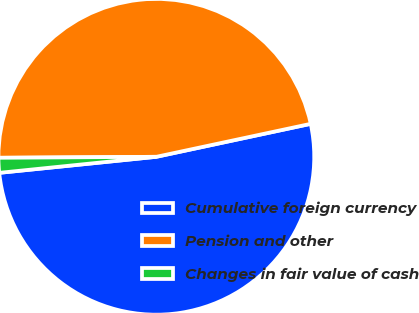<chart> <loc_0><loc_0><loc_500><loc_500><pie_chart><fcel>Cumulative foreign currency<fcel>Pension and other<fcel>Changes in fair value of cash<nl><fcel>51.73%<fcel>46.75%<fcel>1.52%<nl></chart> 